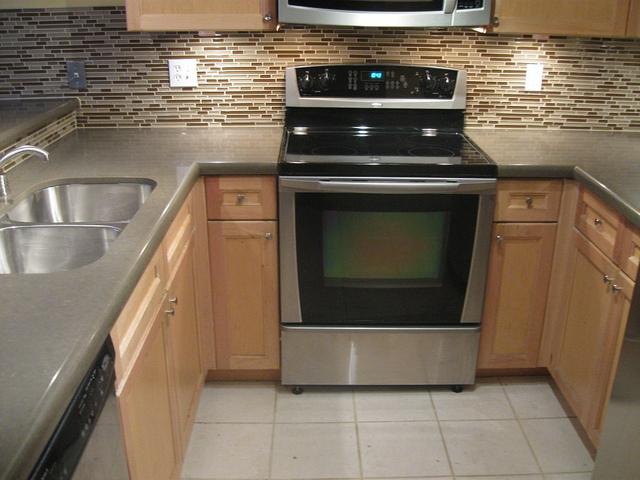What is the object in the center used for?
Quick response, please. Cooking. Are the countertops bare?
Give a very brief answer. Yes. Is this a kitchen?
Short answer required. Yes. How modern is the kitchen?
Write a very short answer. Very. 